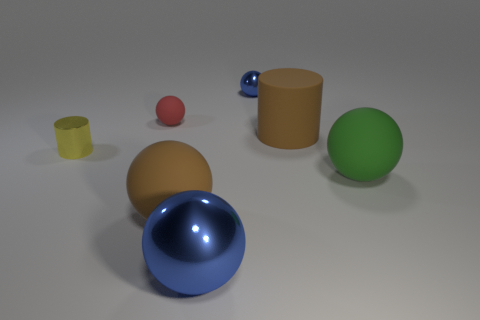Subtract all cyan cylinders. How many blue balls are left? 2 Subtract all red balls. How many balls are left? 4 Subtract all big brown rubber spheres. How many spheres are left? 4 Add 3 purple cubes. How many objects exist? 10 Subtract 3 spheres. How many spheres are left? 2 Subtract all gray spheres. Subtract all blue cubes. How many spheres are left? 5 Subtract 0 cyan cubes. How many objects are left? 7 Subtract all spheres. How many objects are left? 2 Subtract all red things. Subtract all yellow shiny cylinders. How many objects are left? 5 Add 7 rubber cylinders. How many rubber cylinders are left? 8 